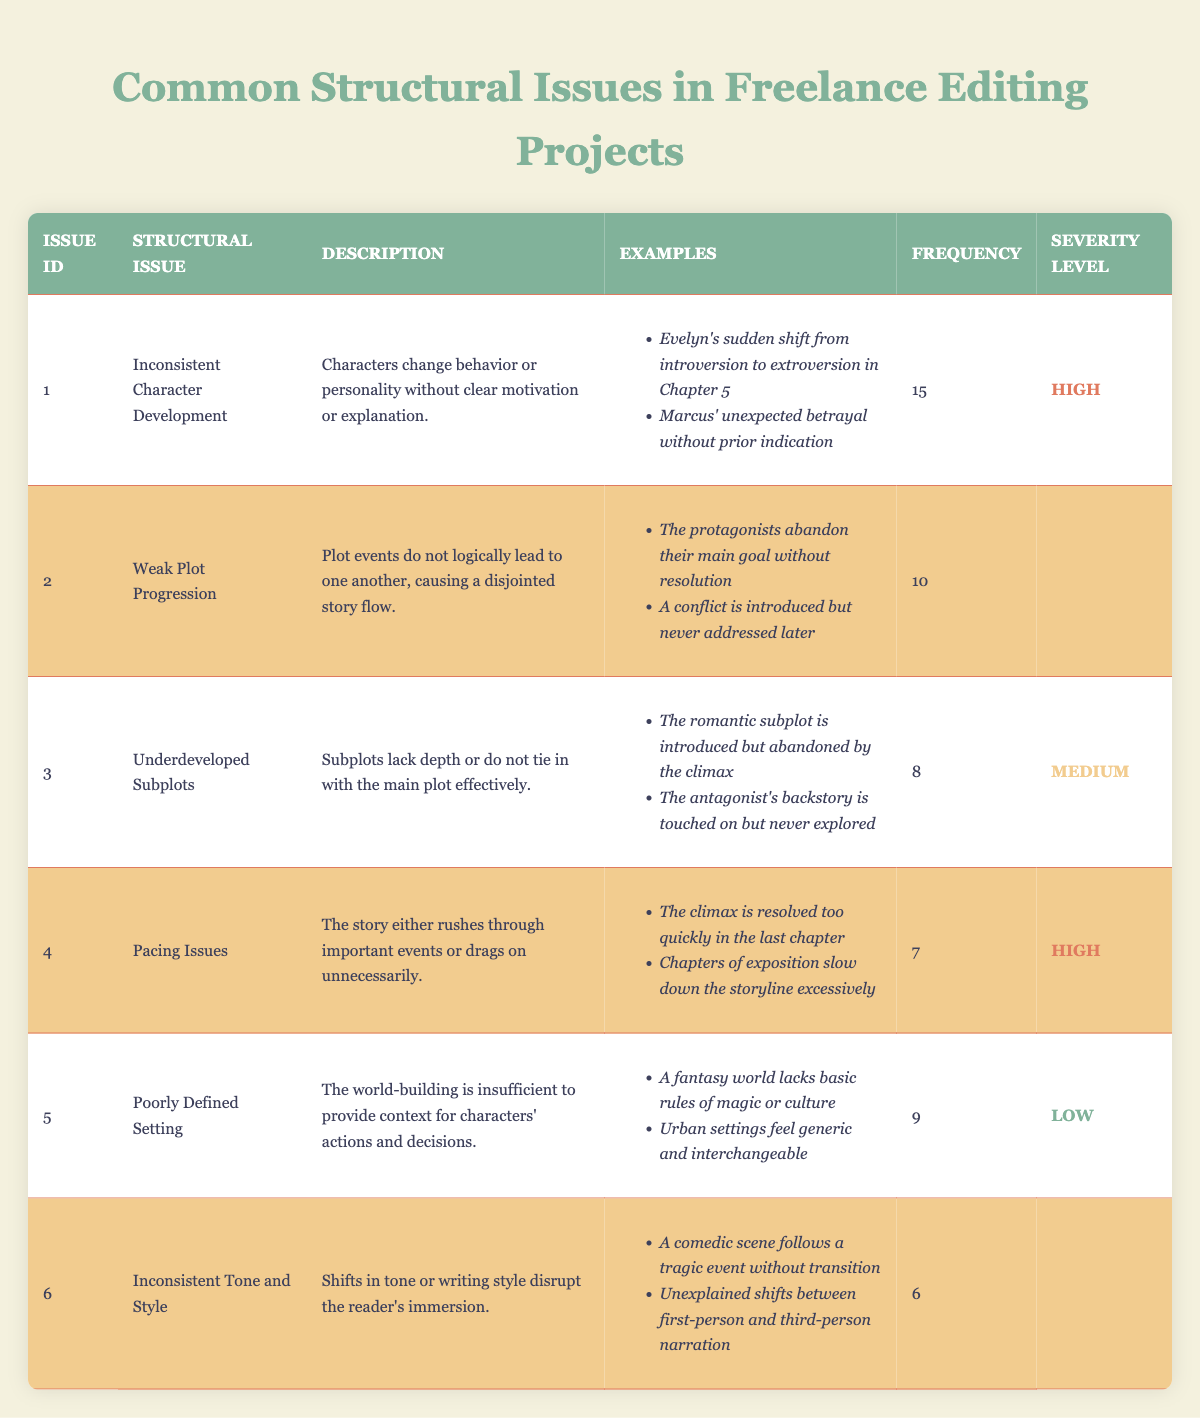What is the most frequent structural issue identified in freelance editing projects? According to the table, the issue labeled "Inconsistent Character Development" has a frequency of 15, which is the highest compared to other issues.
Answer: Inconsistent Character Development What are the severity levels of "Inconsistent Tone and Style" and "Poorly Defined Setting"? The severity level for "Inconsistent Tone and Style" is Medium, while for "Poorly Defined Setting," it is Low. These levels can be found in the corresponding rows under the Severity Level column.
Answer: Medium and Low How many issues have a high severity level? There are two issues that are classified as having a high severity level, which are "Inconsistent Character Development" and "Pacing Issues" as indicated in the Severity Level column.
Answer: 2 What is the average frequency of the identified structural issues? To find the average frequency, add up the frequencies: (15 + 10 + 8 + 7 + 9 + 6) = 55. Then divide the total by the number of issues, which is 6: 55/6 = 9.17.
Answer: 9.17 Is "Underdeveloped Subplots" a high severity issue? No, "Underdeveloped Subplots" has a severity level of Medium, as indicated in the table.
Answer: No Which structural issue has the lowest frequency? The issue with the lowest frequency is "Inconsistent Tone and Style," which has a frequency of 6. This is the lowest number present in the Frequency column.
Answer: Inconsistent Tone and Style What is the difference in frequency between the most frequent and least frequent issue? The most frequent issue is "Inconsistent Character Development" with a frequency of 15, and the least frequent, "Inconsistent Tone and Style," has a frequency of 6. The difference is 15 - 6 = 9.
Answer: 9 What are the examples listed under the "Weak Plot Progression" issue? The table provides two examples for "Weak Plot Progression": "The protagonists abandon their main goal without resolution" and "A conflict is introduced but never addressed later." These can be found in the Examples column for the corresponding row.
Answer: Protagonists abandon their main goal without resolution; conflict is introduced but never addressed later 